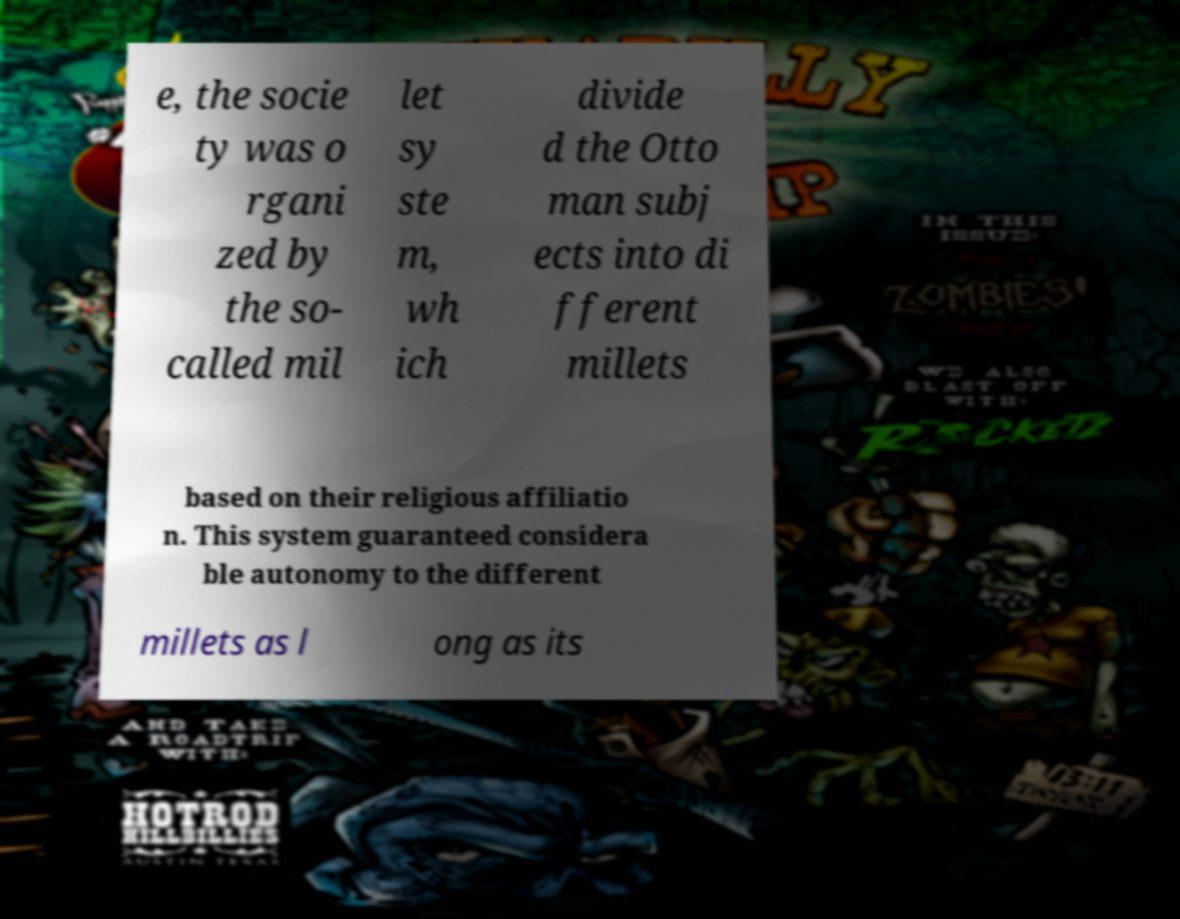Please read and relay the text visible in this image. What does it say? e, the socie ty was o rgani zed by the so- called mil let sy ste m, wh ich divide d the Otto man subj ects into di fferent millets based on their religious affiliatio n. This system guaranteed considera ble autonomy to the different millets as l ong as its 